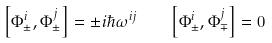Convert formula to latex. <formula><loc_0><loc_0><loc_500><loc_500>\left [ \Phi ^ { i } _ { \pm } , \Phi ^ { j } _ { \pm } \right ] = \pm i \hbar { \omega } ^ { i j } \quad \left [ \Phi ^ { i } _ { \pm } , \Phi ^ { j } _ { \mp } \right ] = 0</formula> 